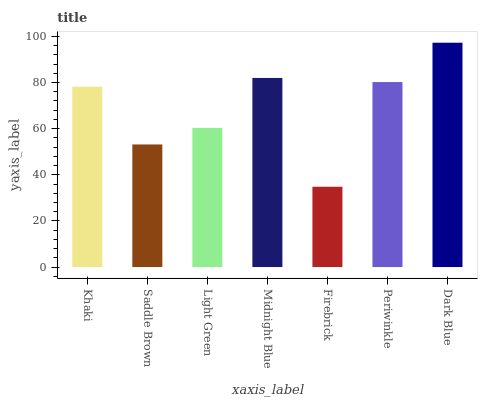Is Firebrick the minimum?
Answer yes or no. Yes. Is Dark Blue the maximum?
Answer yes or no. Yes. Is Saddle Brown the minimum?
Answer yes or no. No. Is Saddle Brown the maximum?
Answer yes or no. No. Is Khaki greater than Saddle Brown?
Answer yes or no. Yes. Is Saddle Brown less than Khaki?
Answer yes or no. Yes. Is Saddle Brown greater than Khaki?
Answer yes or no. No. Is Khaki less than Saddle Brown?
Answer yes or no. No. Is Khaki the high median?
Answer yes or no. Yes. Is Khaki the low median?
Answer yes or no. Yes. Is Firebrick the high median?
Answer yes or no. No. Is Periwinkle the low median?
Answer yes or no. No. 